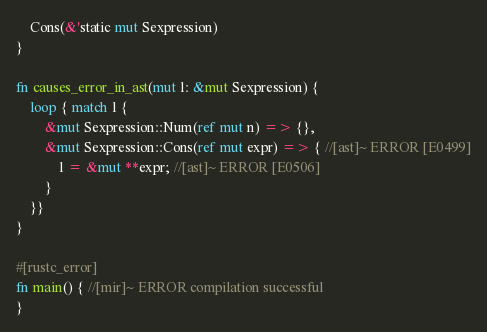Convert code to text. <code><loc_0><loc_0><loc_500><loc_500><_Rust_>    Cons(&'static mut Sexpression)
}

fn causes_error_in_ast(mut l: &mut Sexpression) {
    loop { match l {
        &mut Sexpression::Num(ref mut n) => {},
        &mut Sexpression::Cons(ref mut expr) => { //[ast]~ ERROR [E0499]
            l = &mut **expr; //[ast]~ ERROR [E0506]
        }
    }}
}

#[rustc_error]
fn main() { //[mir]~ ERROR compilation successful
}
</code> 